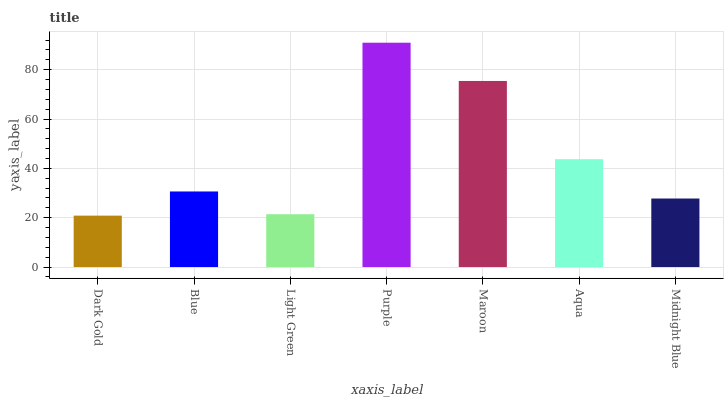Is Dark Gold the minimum?
Answer yes or no. Yes. Is Purple the maximum?
Answer yes or no. Yes. Is Blue the minimum?
Answer yes or no. No. Is Blue the maximum?
Answer yes or no. No. Is Blue greater than Dark Gold?
Answer yes or no. Yes. Is Dark Gold less than Blue?
Answer yes or no. Yes. Is Dark Gold greater than Blue?
Answer yes or no. No. Is Blue less than Dark Gold?
Answer yes or no. No. Is Blue the high median?
Answer yes or no. Yes. Is Blue the low median?
Answer yes or no. Yes. Is Midnight Blue the high median?
Answer yes or no. No. Is Dark Gold the low median?
Answer yes or no. No. 